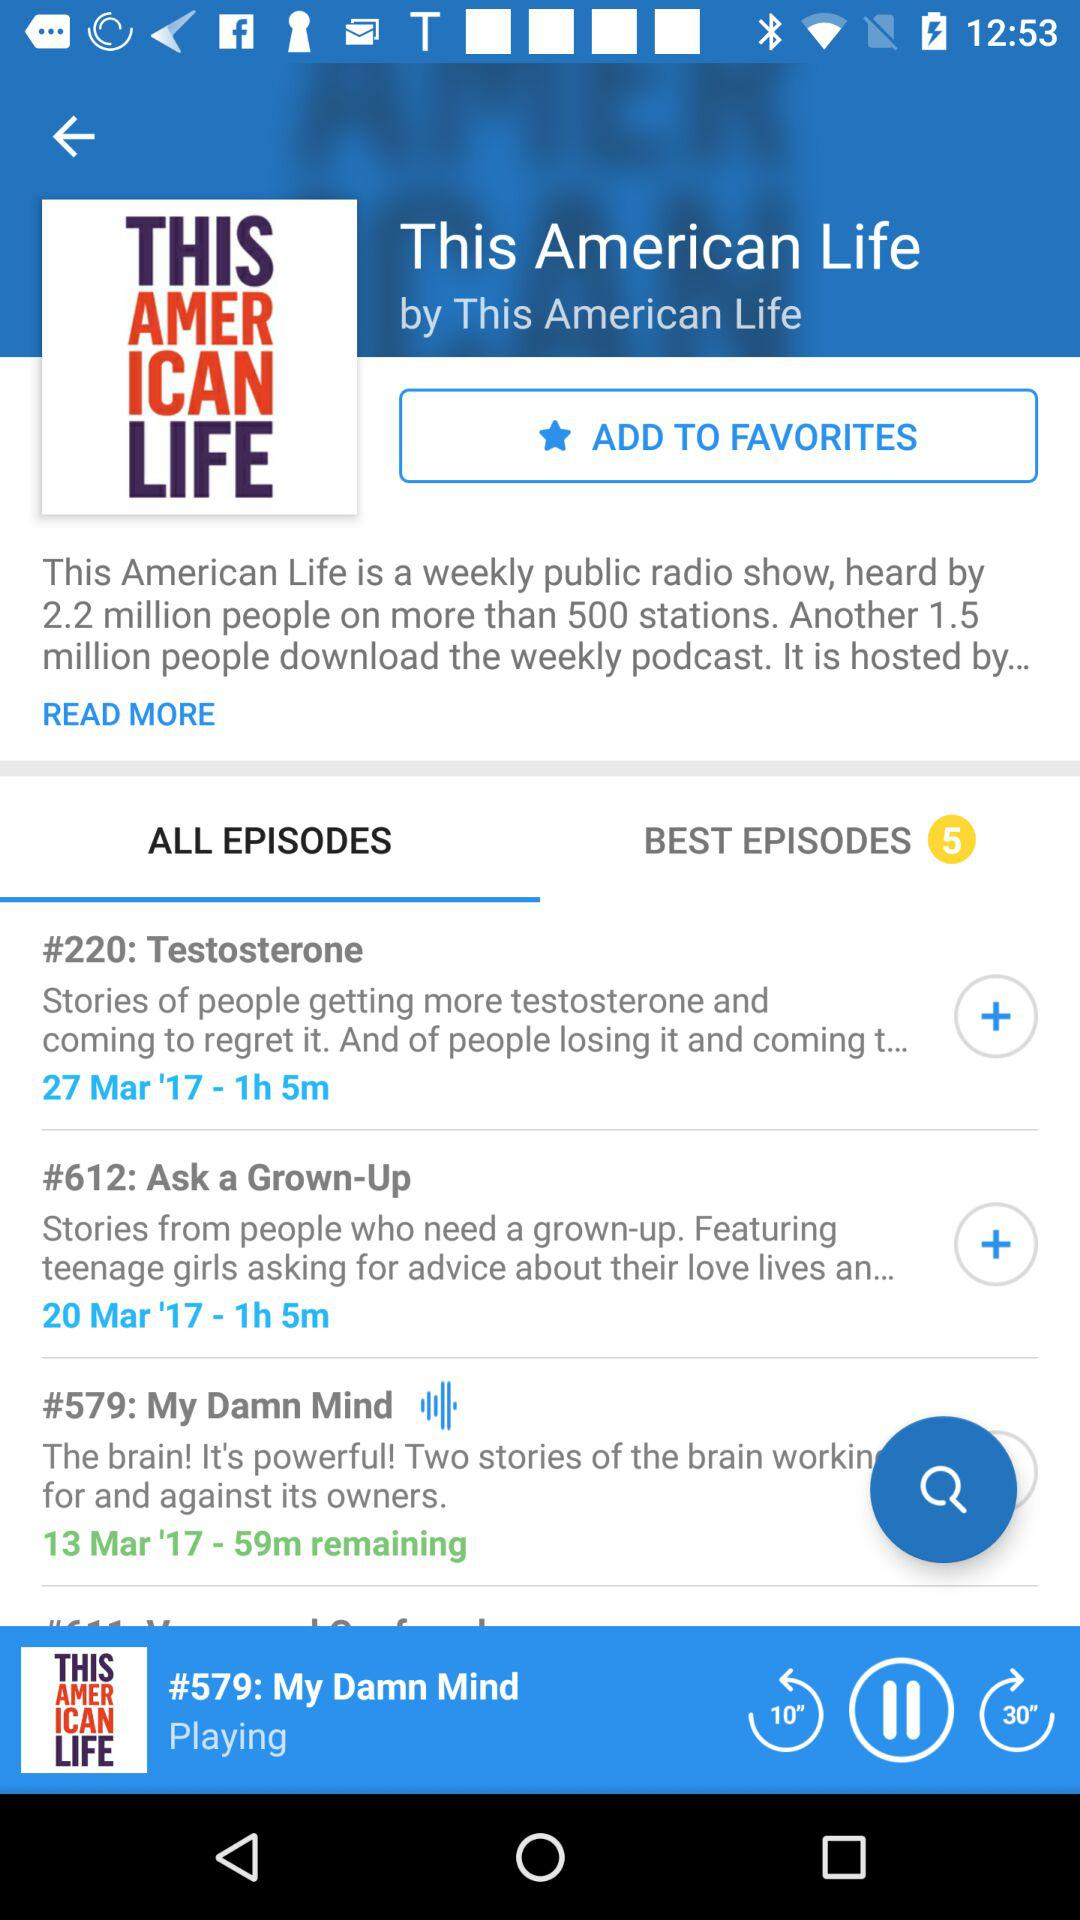When was episode 220 released? Episode 220 was released on March 27, 2017. 